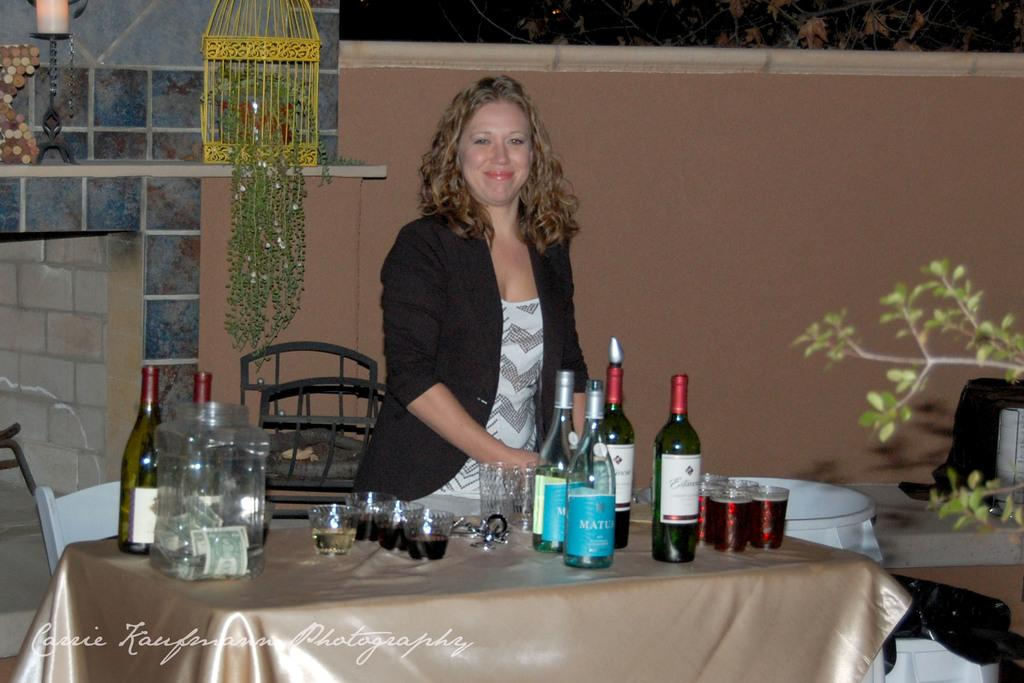What is the main subject of the image? There is a person in the image. What is the person wearing? The person is wearing a black dress. Where is the person located in the image? The person is standing on a table. What objects can be seen in the image besides the person? There are bottles and glasses in the image. What can be seen in the background of the image? There is a wall and plants in the background of the image. What type of science experiment is being conducted on the person's wound in the image? There is no science experiment or wound present in the image; it features a person standing on a table with bottles and glasses nearby. 